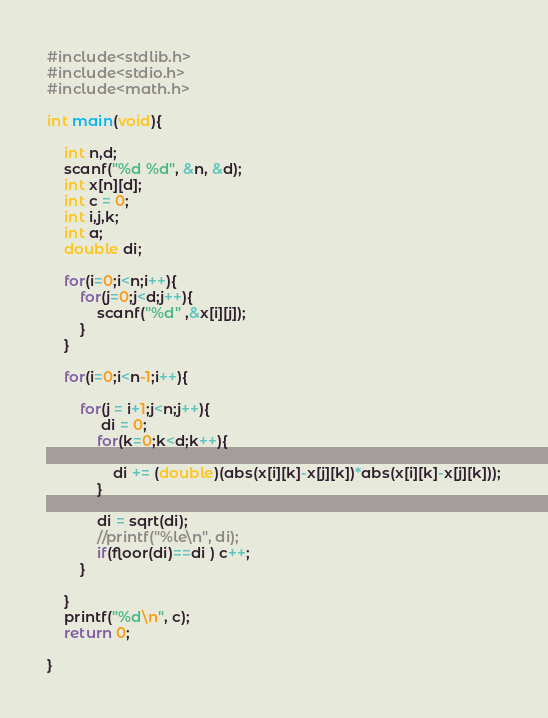Convert code to text. <code><loc_0><loc_0><loc_500><loc_500><_C_>#include<stdlib.h>
#include<stdio.h>
#include<math.h>

int main(void){
    
    int n,d;
    scanf("%d %d", &n, &d);
    int x[n][d];
    int c = 0;
    int i,j,k;
    int a;
    double di;

    for(i=0;i<n;i++){
        for(j=0;j<d;j++){
            scanf("%d" ,&x[i][j]);
        }
    }
    
    for(i=0;i<n-1;i++){
       
        for(j = i+1;j<n;j++){
             di = 0;
            for(k=0;k<d;k++){
                
                di += (double)(abs(x[i][k]-x[j][k])*abs(x[i][k]-x[j][k]));
            }
            
            di = sqrt(di);
            //printf("%le\n", di);
            if(floor(di)==di ) c++;
        }

    }
    printf("%d\n", c);
    return 0;

}</code> 